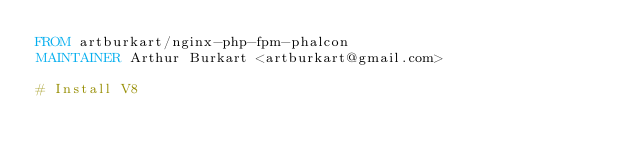<code> <loc_0><loc_0><loc_500><loc_500><_Dockerfile_>FROM artburkart/nginx-php-fpm-phalcon
MAINTAINER Arthur Burkart <artburkart@gmail.com>

# Install V8</code> 